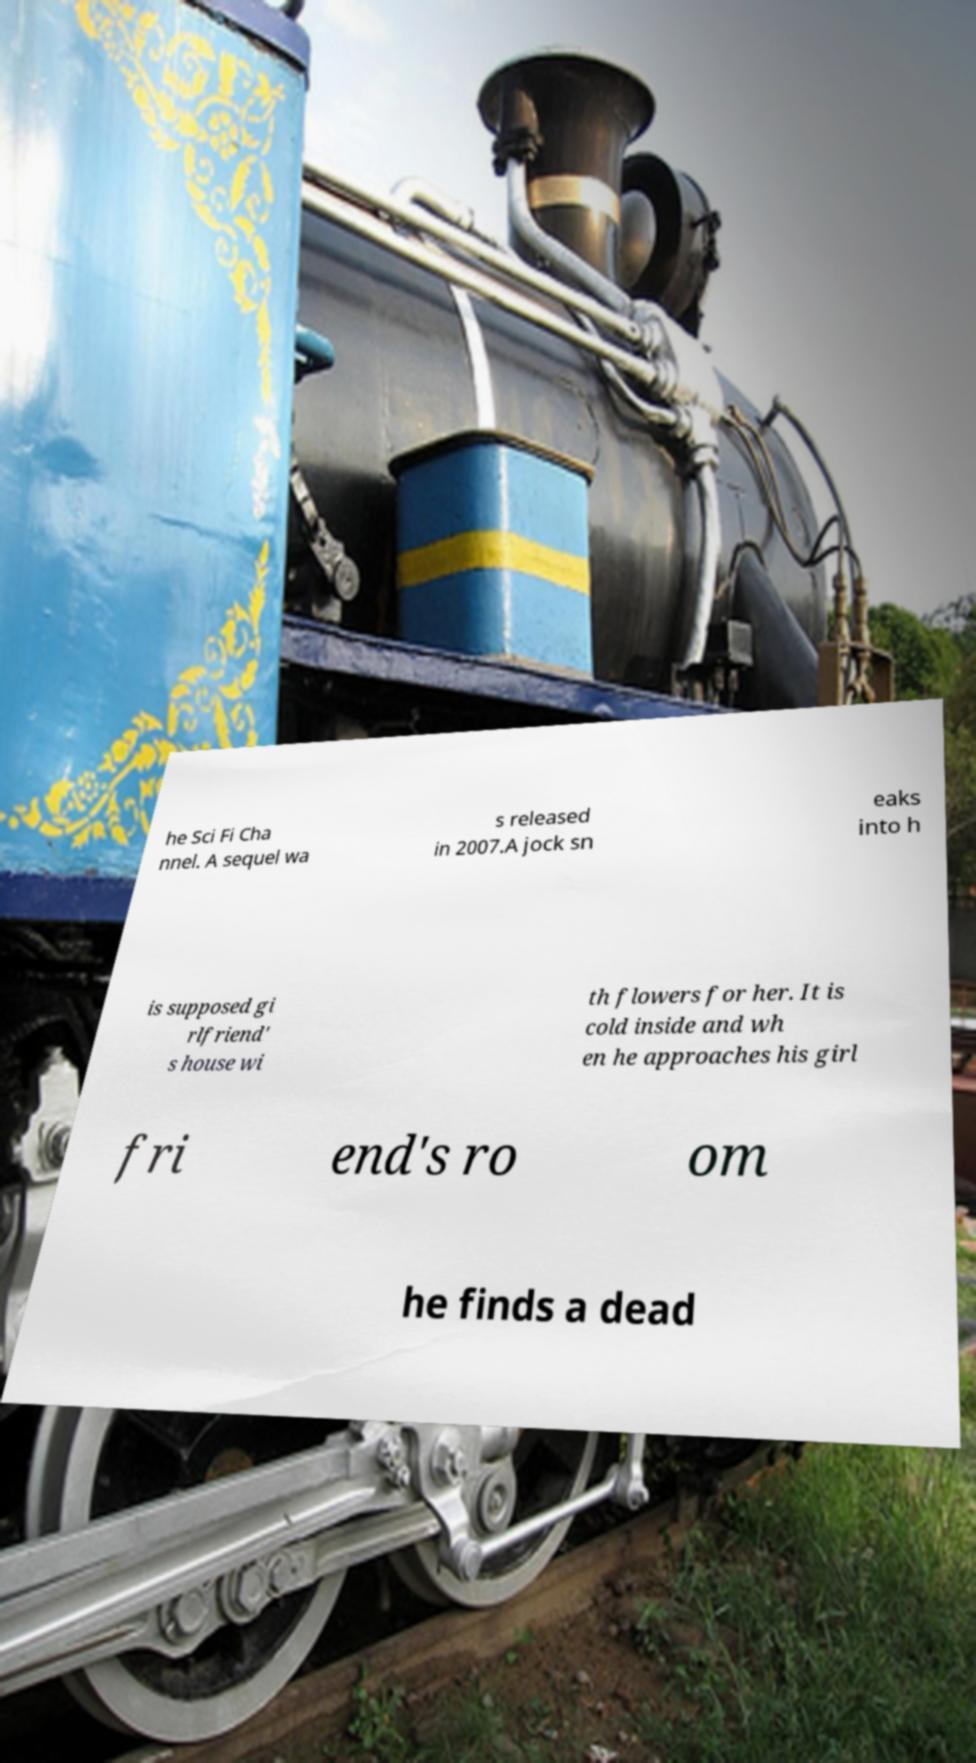I need the written content from this picture converted into text. Can you do that? he Sci Fi Cha nnel. A sequel wa s released in 2007.A jock sn eaks into h is supposed gi rlfriend' s house wi th flowers for her. It is cold inside and wh en he approaches his girl fri end's ro om he finds a dead 